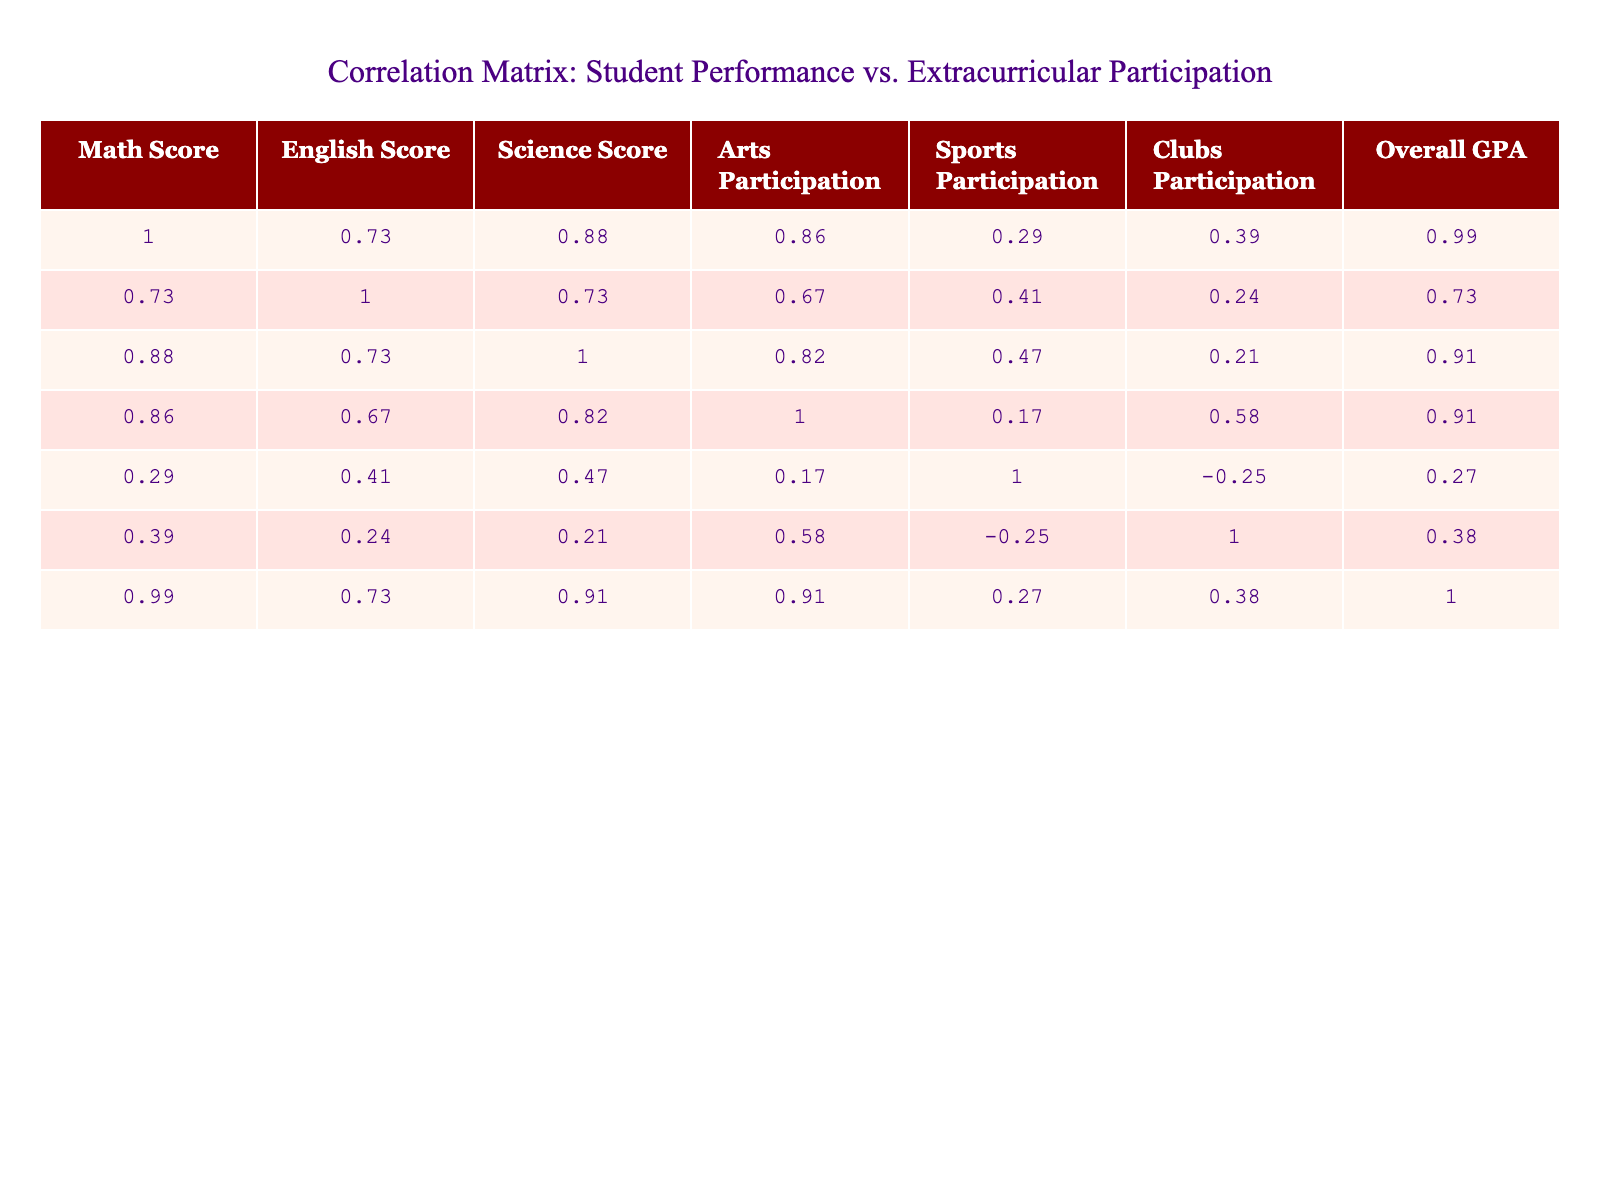What is the correlation between Math Score and Overall GPA? The correlation coefficient for Math Score and Overall GPA can be found in the table. Looking at the table, the value is 0.87, indicating a strong positive correlation between these two metrics. This means that as Math Scores increase, Overall GPA also tends to increase.
Answer: 0.87 Which student has the highest English Score? To find the highest English Score, I compare all the English Scores in the table. The highest score is 92, which belongs to Isabella Anderson.
Answer: Isabella Anderson What is the average Science Score of students who participate in Sports? First, I identify the students who participated in Sports, which are James Smith, Emily Davis, Sophia Wilson, Liam Taylor, Noah Clark. Their respective Science Scores are 85, 95, 80, 87. I calculate the average as follows: (85 + 95 + 80 + 87 + 87) / 5 = 86.8.
Answer: 86.8 Do students who participate in Arts generally have a higher Overall GPA compared to those who do not? To answer this, I can compare the Overall GPAs of students who participate in Arts (Alice, Emily, Sophia, Isabella, Noah) and those who do not (James, Oliver, Liam, Mia). The average GPA for Arts participants is (3.8 + 4.0 + 3.6 + 3.9 + 3.5) / 5 = 3.76, while for non-participants is (3.1 + 2.5 + 2.9 + 2.8) / 4 = 2.83. Since 3.76 is greater than 2.83, it demonstrates that those who participate in Arts tend to have a higher GPA.
Answer: Yes What is the difference in Overall GPA between the highest and lowest performing students? The highest Overall GPA in the table is 4.2 (Benjamin Thompson) and the lowest is 2.5 (Oliver Brown). The difference is calculated as 4.2 - 2.5 = 1.7. This shows quite a distinct gap in overall performance.
Answer: 1.7 